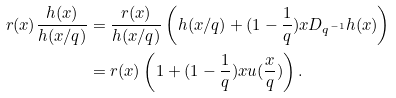Convert formula to latex. <formula><loc_0><loc_0><loc_500><loc_500>r ( x ) \frac { h ( x ) } { h ( x / q ) } & = \frac { r ( x ) } { h ( x / q ) } \left ( h ( x / q ) + ( 1 - \frac { 1 } { q } ) x D _ { q ^ { - 1 } } h ( x ) \right ) \\ & = r ( x ) \left ( 1 + ( 1 - \frac { 1 } { q } ) x u ( \frac { x } { q } ) \right ) .</formula> 